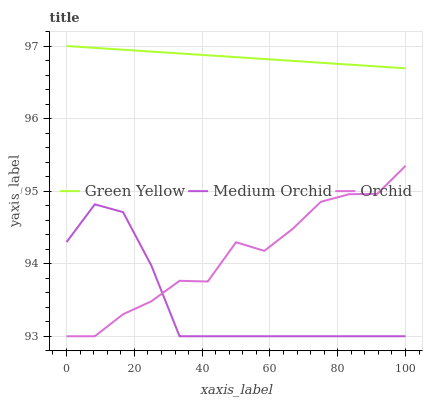Does Medium Orchid have the minimum area under the curve?
Answer yes or no. Yes. Does Green Yellow have the maximum area under the curve?
Answer yes or no. Yes. Does Orchid have the minimum area under the curve?
Answer yes or no. No. Does Orchid have the maximum area under the curve?
Answer yes or no. No. Is Green Yellow the smoothest?
Answer yes or no. Yes. Is Orchid the roughest?
Answer yes or no. Yes. Is Orchid the smoothest?
Answer yes or no. No. Is Green Yellow the roughest?
Answer yes or no. No. Does Medium Orchid have the lowest value?
Answer yes or no. Yes. Does Green Yellow have the lowest value?
Answer yes or no. No. Does Green Yellow have the highest value?
Answer yes or no. Yes. Does Orchid have the highest value?
Answer yes or no. No. Is Orchid less than Green Yellow?
Answer yes or no. Yes. Is Green Yellow greater than Medium Orchid?
Answer yes or no. Yes. Does Medium Orchid intersect Orchid?
Answer yes or no. Yes. Is Medium Orchid less than Orchid?
Answer yes or no. No. Is Medium Orchid greater than Orchid?
Answer yes or no. No. Does Orchid intersect Green Yellow?
Answer yes or no. No. 